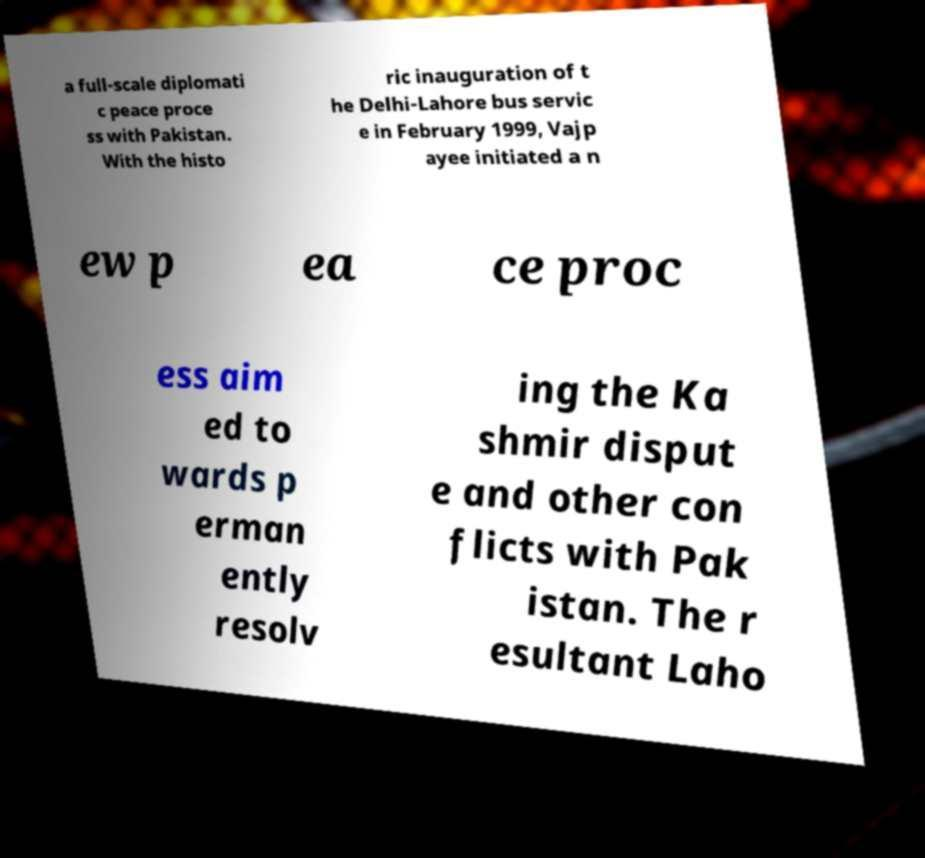Please identify and transcribe the text found in this image. a full-scale diplomati c peace proce ss with Pakistan. With the histo ric inauguration of t he Delhi-Lahore bus servic e in February 1999, Vajp ayee initiated a n ew p ea ce proc ess aim ed to wards p erman ently resolv ing the Ka shmir disput e and other con flicts with Pak istan. The r esultant Laho 